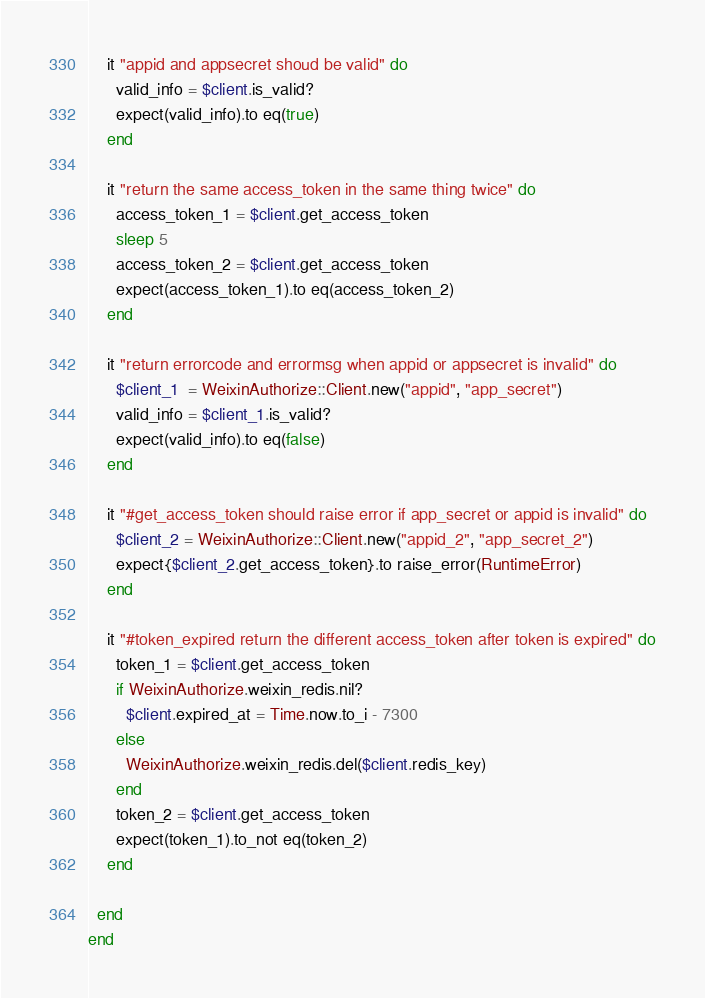Convert code to text. <code><loc_0><loc_0><loc_500><loc_500><_Ruby_>
    it "appid and appsecret shoud be valid" do
      valid_info = $client.is_valid?
      expect(valid_info).to eq(true)
    end

    it "return the same access_token in the same thing twice" do
      access_token_1 = $client.get_access_token
      sleep 5
      access_token_2 = $client.get_access_token
      expect(access_token_1).to eq(access_token_2)
    end

    it "return errorcode and errormsg when appid or appsecret is invalid" do
      $client_1  = WeixinAuthorize::Client.new("appid", "app_secret")
      valid_info = $client_1.is_valid?
      expect(valid_info).to eq(false)
    end

    it "#get_access_token should raise error if app_secret or appid is invalid" do
      $client_2 = WeixinAuthorize::Client.new("appid_2", "app_secret_2")
      expect{$client_2.get_access_token}.to raise_error(RuntimeError)
    end

    it "#token_expired return the different access_token after token is expired" do
      token_1 = $client.get_access_token
      if WeixinAuthorize.weixin_redis.nil?
        $client.expired_at = Time.now.to_i - 7300
      else
        WeixinAuthorize.weixin_redis.del($client.redis_key)
      end
      token_2 = $client.get_access_token
      expect(token_1).to_not eq(token_2)
    end

  end
end
</code> 